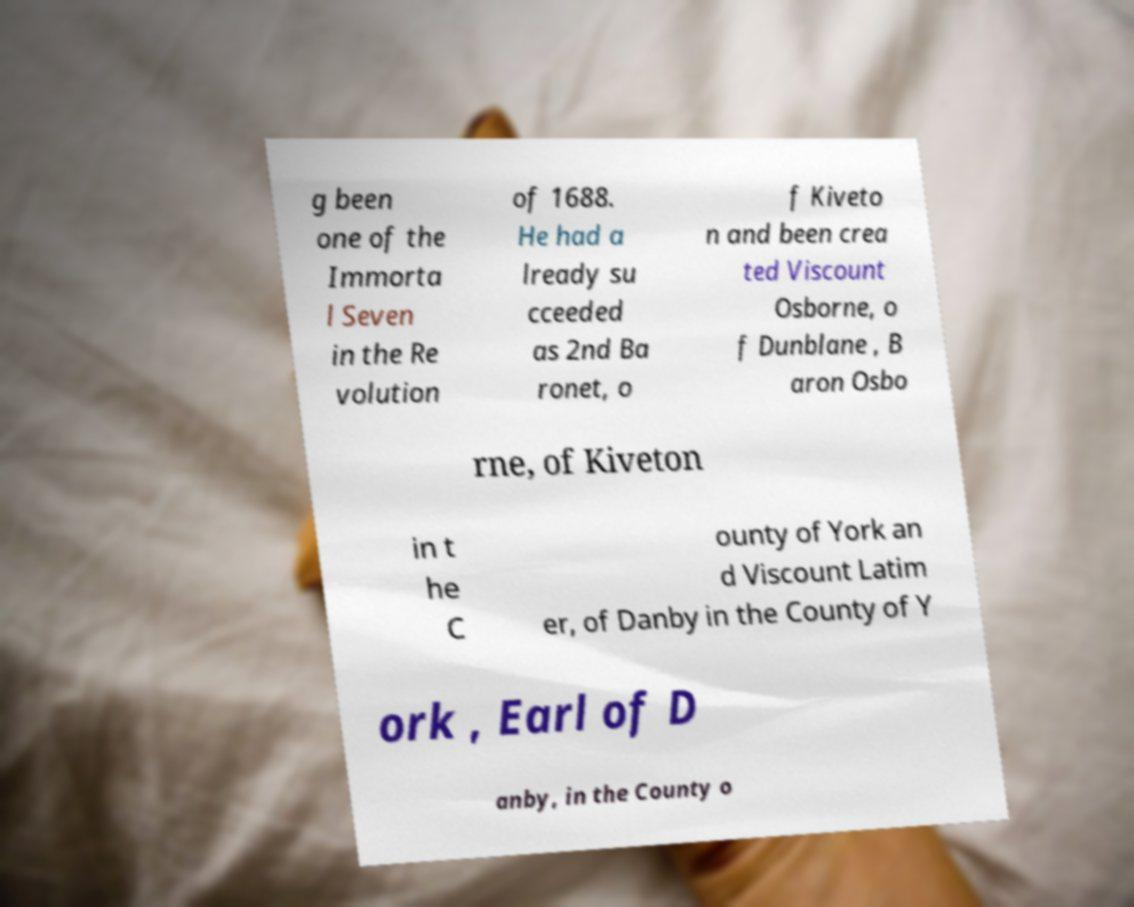Could you assist in decoding the text presented in this image and type it out clearly? g been one of the Immorta l Seven in the Re volution of 1688. He had a lready su cceeded as 2nd Ba ronet, o f Kiveto n and been crea ted Viscount Osborne, o f Dunblane , B aron Osbo rne, of Kiveton in t he C ounty of York an d Viscount Latim er, of Danby in the County of Y ork , Earl of D anby, in the County o 